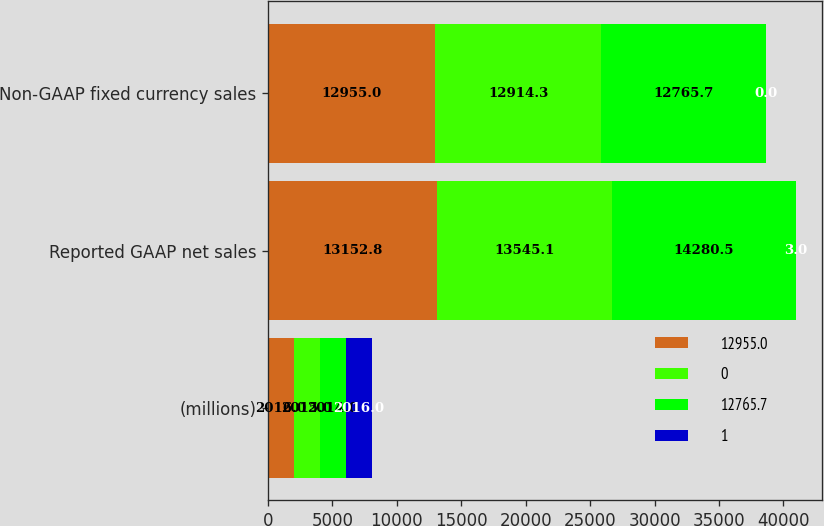<chart> <loc_0><loc_0><loc_500><loc_500><stacked_bar_chart><ecel><fcel>(millions)<fcel>Reported GAAP net sales<fcel>Non-GAAP fixed currency sales<nl><fcel>12955<fcel>2016<fcel>13152.8<fcel>12955<nl><fcel>0<fcel>2015<fcel>13545.1<fcel>12914.3<nl><fcel>12765.7<fcel>2014<fcel>14280.5<fcel>12765.7<nl><fcel>1<fcel>2016<fcel>3<fcel>0<nl></chart> 